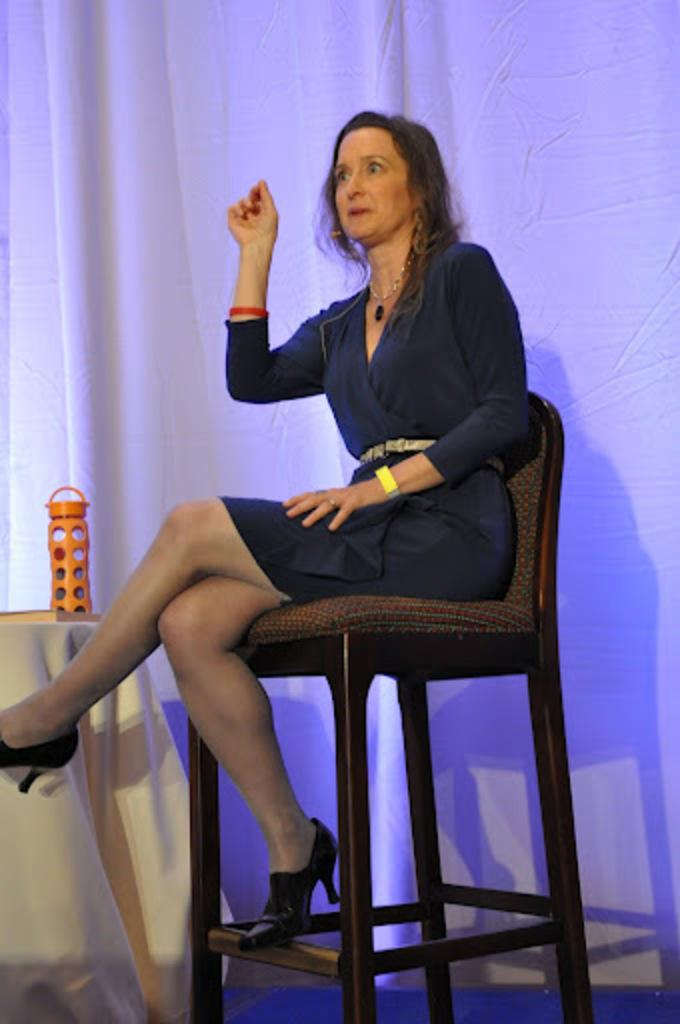What is the lady doing in the image? The lady is sitting on a chair in the image. What is located beside the lady? There is a table beside the lady. What object can be seen on the table? There is a bottle on the table. What can be seen in the background of the image? There is a curtain in the background of the image. How many girls are playing with the beast in the image? There are no girls or beasts present in the image. 